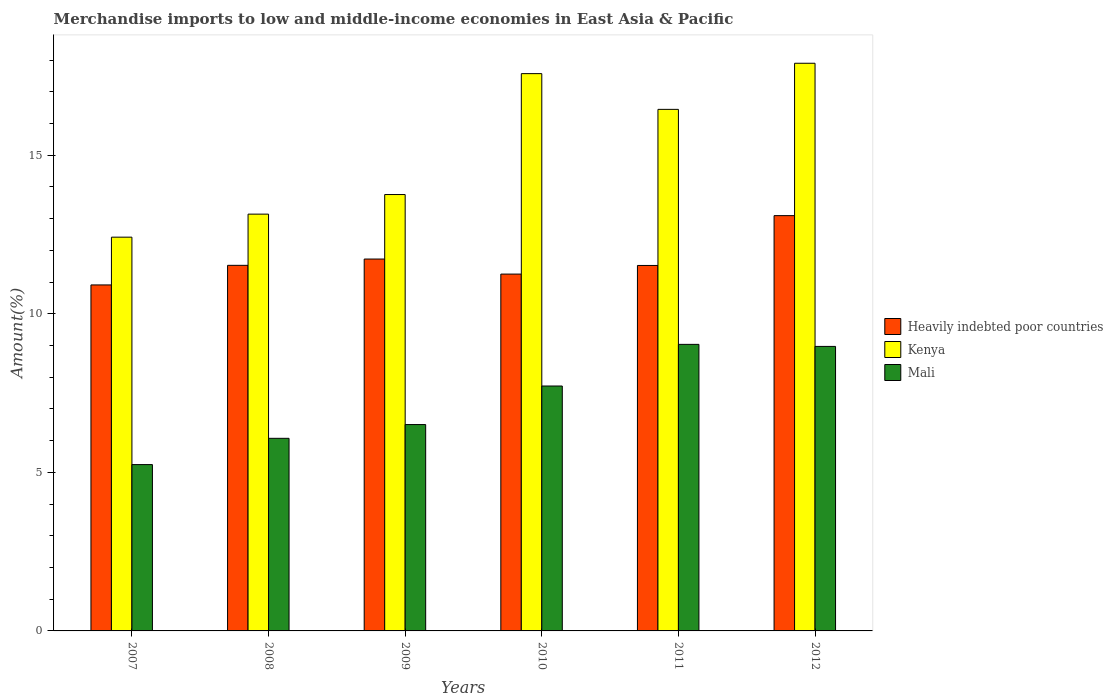How many groups of bars are there?
Your answer should be very brief. 6. How many bars are there on the 5th tick from the left?
Give a very brief answer. 3. How many bars are there on the 6th tick from the right?
Your answer should be compact. 3. In how many cases, is the number of bars for a given year not equal to the number of legend labels?
Your answer should be compact. 0. What is the percentage of amount earned from merchandise imports in Heavily indebted poor countries in 2009?
Provide a short and direct response. 11.73. Across all years, what is the maximum percentage of amount earned from merchandise imports in Kenya?
Offer a terse response. 17.9. Across all years, what is the minimum percentage of amount earned from merchandise imports in Kenya?
Provide a short and direct response. 12.42. What is the total percentage of amount earned from merchandise imports in Heavily indebted poor countries in the graph?
Make the answer very short. 70.03. What is the difference between the percentage of amount earned from merchandise imports in Kenya in 2010 and that in 2011?
Provide a short and direct response. 1.13. What is the difference between the percentage of amount earned from merchandise imports in Heavily indebted poor countries in 2011 and the percentage of amount earned from merchandise imports in Mali in 2009?
Provide a succinct answer. 5.02. What is the average percentage of amount earned from merchandise imports in Heavily indebted poor countries per year?
Your answer should be very brief. 11.67. In the year 2007, what is the difference between the percentage of amount earned from merchandise imports in Heavily indebted poor countries and percentage of amount earned from merchandise imports in Kenya?
Make the answer very short. -1.51. What is the ratio of the percentage of amount earned from merchandise imports in Heavily indebted poor countries in 2007 to that in 2009?
Your response must be concise. 0.93. Is the percentage of amount earned from merchandise imports in Heavily indebted poor countries in 2009 less than that in 2012?
Ensure brevity in your answer.  Yes. Is the difference between the percentage of amount earned from merchandise imports in Heavily indebted poor countries in 2008 and 2012 greater than the difference between the percentage of amount earned from merchandise imports in Kenya in 2008 and 2012?
Give a very brief answer. Yes. What is the difference between the highest and the second highest percentage of amount earned from merchandise imports in Heavily indebted poor countries?
Keep it short and to the point. 1.37. What is the difference between the highest and the lowest percentage of amount earned from merchandise imports in Kenya?
Your response must be concise. 5.48. Is the sum of the percentage of amount earned from merchandise imports in Mali in 2008 and 2010 greater than the maximum percentage of amount earned from merchandise imports in Kenya across all years?
Provide a succinct answer. No. What does the 2nd bar from the left in 2011 represents?
Give a very brief answer. Kenya. What does the 3rd bar from the right in 2011 represents?
Make the answer very short. Heavily indebted poor countries. How many bars are there?
Your response must be concise. 18. Are all the bars in the graph horizontal?
Your answer should be very brief. No. How many years are there in the graph?
Your response must be concise. 6. Are the values on the major ticks of Y-axis written in scientific E-notation?
Provide a short and direct response. No. How many legend labels are there?
Provide a succinct answer. 3. What is the title of the graph?
Give a very brief answer. Merchandise imports to low and middle-income economies in East Asia & Pacific. What is the label or title of the X-axis?
Your answer should be very brief. Years. What is the label or title of the Y-axis?
Provide a short and direct response. Amount(%). What is the Amount(%) in Heavily indebted poor countries in 2007?
Provide a short and direct response. 10.91. What is the Amount(%) of Kenya in 2007?
Offer a terse response. 12.42. What is the Amount(%) in Mali in 2007?
Provide a short and direct response. 5.24. What is the Amount(%) in Heavily indebted poor countries in 2008?
Offer a terse response. 11.53. What is the Amount(%) in Kenya in 2008?
Give a very brief answer. 13.14. What is the Amount(%) of Mali in 2008?
Your response must be concise. 6.07. What is the Amount(%) of Heavily indebted poor countries in 2009?
Your response must be concise. 11.73. What is the Amount(%) of Kenya in 2009?
Your answer should be very brief. 13.76. What is the Amount(%) in Mali in 2009?
Your answer should be compact. 6.51. What is the Amount(%) of Heavily indebted poor countries in 2010?
Offer a very short reply. 11.25. What is the Amount(%) of Kenya in 2010?
Ensure brevity in your answer.  17.57. What is the Amount(%) of Mali in 2010?
Offer a terse response. 7.72. What is the Amount(%) of Heavily indebted poor countries in 2011?
Your answer should be very brief. 11.52. What is the Amount(%) in Kenya in 2011?
Your response must be concise. 16.44. What is the Amount(%) of Mali in 2011?
Give a very brief answer. 9.04. What is the Amount(%) in Heavily indebted poor countries in 2012?
Your response must be concise. 13.09. What is the Amount(%) in Kenya in 2012?
Make the answer very short. 17.9. What is the Amount(%) in Mali in 2012?
Ensure brevity in your answer.  8.97. Across all years, what is the maximum Amount(%) of Heavily indebted poor countries?
Provide a succinct answer. 13.09. Across all years, what is the maximum Amount(%) of Kenya?
Ensure brevity in your answer.  17.9. Across all years, what is the maximum Amount(%) in Mali?
Keep it short and to the point. 9.04. Across all years, what is the minimum Amount(%) in Heavily indebted poor countries?
Your answer should be compact. 10.91. Across all years, what is the minimum Amount(%) in Kenya?
Provide a succinct answer. 12.42. Across all years, what is the minimum Amount(%) in Mali?
Ensure brevity in your answer.  5.24. What is the total Amount(%) of Heavily indebted poor countries in the graph?
Your response must be concise. 70.03. What is the total Amount(%) of Kenya in the graph?
Your response must be concise. 91.23. What is the total Amount(%) in Mali in the graph?
Ensure brevity in your answer.  43.55. What is the difference between the Amount(%) of Heavily indebted poor countries in 2007 and that in 2008?
Your answer should be compact. -0.62. What is the difference between the Amount(%) in Kenya in 2007 and that in 2008?
Give a very brief answer. -0.73. What is the difference between the Amount(%) in Mali in 2007 and that in 2008?
Ensure brevity in your answer.  -0.83. What is the difference between the Amount(%) of Heavily indebted poor countries in 2007 and that in 2009?
Provide a short and direct response. -0.82. What is the difference between the Amount(%) in Kenya in 2007 and that in 2009?
Give a very brief answer. -1.34. What is the difference between the Amount(%) of Mali in 2007 and that in 2009?
Your answer should be very brief. -1.26. What is the difference between the Amount(%) of Heavily indebted poor countries in 2007 and that in 2010?
Make the answer very short. -0.34. What is the difference between the Amount(%) in Kenya in 2007 and that in 2010?
Make the answer very short. -5.16. What is the difference between the Amount(%) in Mali in 2007 and that in 2010?
Provide a short and direct response. -2.48. What is the difference between the Amount(%) of Heavily indebted poor countries in 2007 and that in 2011?
Offer a very short reply. -0.61. What is the difference between the Amount(%) of Kenya in 2007 and that in 2011?
Keep it short and to the point. -4.03. What is the difference between the Amount(%) in Mali in 2007 and that in 2011?
Your response must be concise. -3.79. What is the difference between the Amount(%) in Heavily indebted poor countries in 2007 and that in 2012?
Provide a short and direct response. -2.19. What is the difference between the Amount(%) of Kenya in 2007 and that in 2012?
Keep it short and to the point. -5.48. What is the difference between the Amount(%) of Mali in 2007 and that in 2012?
Give a very brief answer. -3.73. What is the difference between the Amount(%) in Heavily indebted poor countries in 2008 and that in 2009?
Make the answer very short. -0.2. What is the difference between the Amount(%) of Kenya in 2008 and that in 2009?
Make the answer very short. -0.62. What is the difference between the Amount(%) in Mali in 2008 and that in 2009?
Offer a terse response. -0.43. What is the difference between the Amount(%) in Heavily indebted poor countries in 2008 and that in 2010?
Give a very brief answer. 0.28. What is the difference between the Amount(%) of Kenya in 2008 and that in 2010?
Keep it short and to the point. -4.43. What is the difference between the Amount(%) in Mali in 2008 and that in 2010?
Offer a terse response. -1.65. What is the difference between the Amount(%) of Heavily indebted poor countries in 2008 and that in 2011?
Your response must be concise. 0. What is the difference between the Amount(%) in Kenya in 2008 and that in 2011?
Give a very brief answer. -3.3. What is the difference between the Amount(%) of Mali in 2008 and that in 2011?
Give a very brief answer. -2.96. What is the difference between the Amount(%) in Heavily indebted poor countries in 2008 and that in 2012?
Provide a short and direct response. -1.57. What is the difference between the Amount(%) in Kenya in 2008 and that in 2012?
Give a very brief answer. -4.76. What is the difference between the Amount(%) in Mali in 2008 and that in 2012?
Offer a very short reply. -2.9. What is the difference between the Amount(%) of Heavily indebted poor countries in 2009 and that in 2010?
Provide a short and direct response. 0.47. What is the difference between the Amount(%) of Kenya in 2009 and that in 2010?
Give a very brief answer. -3.81. What is the difference between the Amount(%) of Mali in 2009 and that in 2010?
Provide a short and direct response. -1.22. What is the difference between the Amount(%) in Heavily indebted poor countries in 2009 and that in 2011?
Offer a terse response. 0.2. What is the difference between the Amount(%) in Kenya in 2009 and that in 2011?
Provide a short and direct response. -2.69. What is the difference between the Amount(%) of Mali in 2009 and that in 2011?
Keep it short and to the point. -2.53. What is the difference between the Amount(%) in Heavily indebted poor countries in 2009 and that in 2012?
Give a very brief answer. -1.37. What is the difference between the Amount(%) in Kenya in 2009 and that in 2012?
Provide a succinct answer. -4.14. What is the difference between the Amount(%) in Mali in 2009 and that in 2012?
Ensure brevity in your answer.  -2.46. What is the difference between the Amount(%) of Heavily indebted poor countries in 2010 and that in 2011?
Keep it short and to the point. -0.27. What is the difference between the Amount(%) of Kenya in 2010 and that in 2011?
Your answer should be compact. 1.13. What is the difference between the Amount(%) of Mali in 2010 and that in 2011?
Ensure brevity in your answer.  -1.31. What is the difference between the Amount(%) of Heavily indebted poor countries in 2010 and that in 2012?
Your answer should be very brief. -1.84. What is the difference between the Amount(%) in Kenya in 2010 and that in 2012?
Keep it short and to the point. -0.33. What is the difference between the Amount(%) in Mali in 2010 and that in 2012?
Offer a terse response. -1.25. What is the difference between the Amount(%) of Heavily indebted poor countries in 2011 and that in 2012?
Make the answer very short. -1.57. What is the difference between the Amount(%) of Kenya in 2011 and that in 2012?
Make the answer very short. -1.45. What is the difference between the Amount(%) of Mali in 2011 and that in 2012?
Your answer should be very brief. 0.06. What is the difference between the Amount(%) of Heavily indebted poor countries in 2007 and the Amount(%) of Kenya in 2008?
Ensure brevity in your answer.  -2.23. What is the difference between the Amount(%) of Heavily indebted poor countries in 2007 and the Amount(%) of Mali in 2008?
Provide a succinct answer. 4.84. What is the difference between the Amount(%) in Kenya in 2007 and the Amount(%) in Mali in 2008?
Your response must be concise. 6.34. What is the difference between the Amount(%) in Heavily indebted poor countries in 2007 and the Amount(%) in Kenya in 2009?
Offer a very short reply. -2.85. What is the difference between the Amount(%) of Heavily indebted poor countries in 2007 and the Amount(%) of Mali in 2009?
Give a very brief answer. 4.4. What is the difference between the Amount(%) of Kenya in 2007 and the Amount(%) of Mali in 2009?
Offer a very short reply. 5.91. What is the difference between the Amount(%) of Heavily indebted poor countries in 2007 and the Amount(%) of Kenya in 2010?
Your response must be concise. -6.66. What is the difference between the Amount(%) in Heavily indebted poor countries in 2007 and the Amount(%) in Mali in 2010?
Your response must be concise. 3.19. What is the difference between the Amount(%) in Kenya in 2007 and the Amount(%) in Mali in 2010?
Your answer should be compact. 4.69. What is the difference between the Amount(%) of Heavily indebted poor countries in 2007 and the Amount(%) of Kenya in 2011?
Your answer should be very brief. -5.54. What is the difference between the Amount(%) of Heavily indebted poor countries in 2007 and the Amount(%) of Mali in 2011?
Your response must be concise. 1.87. What is the difference between the Amount(%) in Kenya in 2007 and the Amount(%) in Mali in 2011?
Your answer should be compact. 3.38. What is the difference between the Amount(%) of Heavily indebted poor countries in 2007 and the Amount(%) of Kenya in 2012?
Give a very brief answer. -6.99. What is the difference between the Amount(%) of Heavily indebted poor countries in 2007 and the Amount(%) of Mali in 2012?
Offer a very short reply. 1.94. What is the difference between the Amount(%) in Kenya in 2007 and the Amount(%) in Mali in 2012?
Your response must be concise. 3.44. What is the difference between the Amount(%) in Heavily indebted poor countries in 2008 and the Amount(%) in Kenya in 2009?
Make the answer very short. -2.23. What is the difference between the Amount(%) of Heavily indebted poor countries in 2008 and the Amount(%) of Mali in 2009?
Your answer should be very brief. 5.02. What is the difference between the Amount(%) of Kenya in 2008 and the Amount(%) of Mali in 2009?
Your answer should be very brief. 6.63. What is the difference between the Amount(%) of Heavily indebted poor countries in 2008 and the Amount(%) of Kenya in 2010?
Your answer should be compact. -6.04. What is the difference between the Amount(%) of Heavily indebted poor countries in 2008 and the Amount(%) of Mali in 2010?
Keep it short and to the point. 3.8. What is the difference between the Amount(%) in Kenya in 2008 and the Amount(%) in Mali in 2010?
Give a very brief answer. 5.42. What is the difference between the Amount(%) of Heavily indebted poor countries in 2008 and the Amount(%) of Kenya in 2011?
Your answer should be compact. -4.92. What is the difference between the Amount(%) of Heavily indebted poor countries in 2008 and the Amount(%) of Mali in 2011?
Offer a terse response. 2.49. What is the difference between the Amount(%) of Kenya in 2008 and the Amount(%) of Mali in 2011?
Provide a short and direct response. 4.11. What is the difference between the Amount(%) of Heavily indebted poor countries in 2008 and the Amount(%) of Kenya in 2012?
Your response must be concise. -6.37. What is the difference between the Amount(%) in Heavily indebted poor countries in 2008 and the Amount(%) in Mali in 2012?
Make the answer very short. 2.56. What is the difference between the Amount(%) in Kenya in 2008 and the Amount(%) in Mali in 2012?
Provide a succinct answer. 4.17. What is the difference between the Amount(%) of Heavily indebted poor countries in 2009 and the Amount(%) of Kenya in 2010?
Provide a short and direct response. -5.85. What is the difference between the Amount(%) in Heavily indebted poor countries in 2009 and the Amount(%) in Mali in 2010?
Offer a terse response. 4. What is the difference between the Amount(%) of Kenya in 2009 and the Amount(%) of Mali in 2010?
Keep it short and to the point. 6.04. What is the difference between the Amount(%) of Heavily indebted poor countries in 2009 and the Amount(%) of Kenya in 2011?
Provide a short and direct response. -4.72. What is the difference between the Amount(%) in Heavily indebted poor countries in 2009 and the Amount(%) in Mali in 2011?
Provide a short and direct response. 2.69. What is the difference between the Amount(%) of Kenya in 2009 and the Amount(%) of Mali in 2011?
Ensure brevity in your answer.  4.72. What is the difference between the Amount(%) in Heavily indebted poor countries in 2009 and the Amount(%) in Kenya in 2012?
Make the answer very short. -6.17. What is the difference between the Amount(%) of Heavily indebted poor countries in 2009 and the Amount(%) of Mali in 2012?
Give a very brief answer. 2.76. What is the difference between the Amount(%) in Kenya in 2009 and the Amount(%) in Mali in 2012?
Your answer should be compact. 4.79. What is the difference between the Amount(%) of Heavily indebted poor countries in 2010 and the Amount(%) of Kenya in 2011?
Provide a short and direct response. -5.19. What is the difference between the Amount(%) of Heavily indebted poor countries in 2010 and the Amount(%) of Mali in 2011?
Your answer should be very brief. 2.22. What is the difference between the Amount(%) in Kenya in 2010 and the Amount(%) in Mali in 2011?
Ensure brevity in your answer.  8.54. What is the difference between the Amount(%) of Heavily indebted poor countries in 2010 and the Amount(%) of Kenya in 2012?
Ensure brevity in your answer.  -6.65. What is the difference between the Amount(%) of Heavily indebted poor countries in 2010 and the Amount(%) of Mali in 2012?
Make the answer very short. 2.28. What is the difference between the Amount(%) in Kenya in 2010 and the Amount(%) in Mali in 2012?
Provide a succinct answer. 8.6. What is the difference between the Amount(%) of Heavily indebted poor countries in 2011 and the Amount(%) of Kenya in 2012?
Keep it short and to the point. -6.38. What is the difference between the Amount(%) in Heavily indebted poor countries in 2011 and the Amount(%) in Mali in 2012?
Offer a very short reply. 2.55. What is the difference between the Amount(%) in Kenya in 2011 and the Amount(%) in Mali in 2012?
Offer a terse response. 7.47. What is the average Amount(%) in Heavily indebted poor countries per year?
Your answer should be very brief. 11.67. What is the average Amount(%) in Kenya per year?
Keep it short and to the point. 15.21. What is the average Amount(%) in Mali per year?
Offer a terse response. 7.26. In the year 2007, what is the difference between the Amount(%) in Heavily indebted poor countries and Amount(%) in Kenya?
Make the answer very short. -1.51. In the year 2007, what is the difference between the Amount(%) in Heavily indebted poor countries and Amount(%) in Mali?
Keep it short and to the point. 5.66. In the year 2007, what is the difference between the Amount(%) of Kenya and Amount(%) of Mali?
Make the answer very short. 7.17. In the year 2008, what is the difference between the Amount(%) in Heavily indebted poor countries and Amount(%) in Kenya?
Give a very brief answer. -1.61. In the year 2008, what is the difference between the Amount(%) in Heavily indebted poor countries and Amount(%) in Mali?
Offer a very short reply. 5.45. In the year 2008, what is the difference between the Amount(%) in Kenya and Amount(%) in Mali?
Make the answer very short. 7.07. In the year 2009, what is the difference between the Amount(%) in Heavily indebted poor countries and Amount(%) in Kenya?
Keep it short and to the point. -2.03. In the year 2009, what is the difference between the Amount(%) of Heavily indebted poor countries and Amount(%) of Mali?
Your answer should be compact. 5.22. In the year 2009, what is the difference between the Amount(%) in Kenya and Amount(%) in Mali?
Your response must be concise. 7.25. In the year 2010, what is the difference between the Amount(%) of Heavily indebted poor countries and Amount(%) of Kenya?
Make the answer very short. -6.32. In the year 2010, what is the difference between the Amount(%) of Heavily indebted poor countries and Amount(%) of Mali?
Provide a succinct answer. 3.53. In the year 2010, what is the difference between the Amount(%) in Kenya and Amount(%) in Mali?
Keep it short and to the point. 9.85. In the year 2011, what is the difference between the Amount(%) of Heavily indebted poor countries and Amount(%) of Kenya?
Your answer should be very brief. -4.92. In the year 2011, what is the difference between the Amount(%) of Heavily indebted poor countries and Amount(%) of Mali?
Your answer should be compact. 2.49. In the year 2011, what is the difference between the Amount(%) in Kenya and Amount(%) in Mali?
Provide a succinct answer. 7.41. In the year 2012, what is the difference between the Amount(%) of Heavily indebted poor countries and Amount(%) of Kenya?
Keep it short and to the point. -4.8. In the year 2012, what is the difference between the Amount(%) in Heavily indebted poor countries and Amount(%) in Mali?
Offer a terse response. 4.12. In the year 2012, what is the difference between the Amount(%) in Kenya and Amount(%) in Mali?
Your answer should be very brief. 8.93. What is the ratio of the Amount(%) in Heavily indebted poor countries in 2007 to that in 2008?
Offer a very short reply. 0.95. What is the ratio of the Amount(%) in Kenya in 2007 to that in 2008?
Offer a very short reply. 0.94. What is the ratio of the Amount(%) of Mali in 2007 to that in 2008?
Your answer should be very brief. 0.86. What is the ratio of the Amount(%) in Heavily indebted poor countries in 2007 to that in 2009?
Provide a short and direct response. 0.93. What is the ratio of the Amount(%) of Kenya in 2007 to that in 2009?
Offer a terse response. 0.9. What is the ratio of the Amount(%) in Mali in 2007 to that in 2009?
Your response must be concise. 0.81. What is the ratio of the Amount(%) in Heavily indebted poor countries in 2007 to that in 2010?
Make the answer very short. 0.97. What is the ratio of the Amount(%) in Kenya in 2007 to that in 2010?
Provide a succinct answer. 0.71. What is the ratio of the Amount(%) in Mali in 2007 to that in 2010?
Keep it short and to the point. 0.68. What is the ratio of the Amount(%) of Heavily indebted poor countries in 2007 to that in 2011?
Provide a short and direct response. 0.95. What is the ratio of the Amount(%) in Kenya in 2007 to that in 2011?
Provide a short and direct response. 0.76. What is the ratio of the Amount(%) in Mali in 2007 to that in 2011?
Keep it short and to the point. 0.58. What is the ratio of the Amount(%) of Heavily indebted poor countries in 2007 to that in 2012?
Your answer should be very brief. 0.83. What is the ratio of the Amount(%) in Kenya in 2007 to that in 2012?
Provide a short and direct response. 0.69. What is the ratio of the Amount(%) in Mali in 2007 to that in 2012?
Make the answer very short. 0.58. What is the ratio of the Amount(%) of Heavily indebted poor countries in 2008 to that in 2009?
Offer a very short reply. 0.98. What is the ratio of the Amount(%) of Kenya in 2008 to that in 2009?
Give a very brief answer. 0.96. What is the ratio of the Amount(%) of Mali in 2008 to that in 2009?
Make the answer very short. 0.93. What is the ratio of the Amount(%) of Heavily indebted poor countries in 2008 to that in 2010?
Your answer should be very brief. 1.02. What is the ratio of the Amount(%) of Kenya in 2008 to that in 2010?
Your response must be concise. 0.75. What is the ratio of the Amount(%) of Mali in 2008 to that in 2010?
Provide a short and direct response. 0.79. What is the ratio of the Amount(%) in Heavily indebted poor countries in 2008 to that in 2011?
Provide a short and direct response. 1. What is the ratio of the Amount(%) of Kenya in 2008 to that in 2011?
Offer a terse response. 0.8. What is the ratio of the Amount(%) in Mali in 2008 to that in 2011?
Your answer should be compact. 0.67. What is the ratio of the Amount(%) of Heavily indebted poor countries in 2008 to that in 2012?
Offer a very short reply. 0.88. What is the ratio of the Amount(%) in Kenya in 2008 to that in 2012?
Give a very brief answer. 0.73. What is the ratio of the Amount(%) in Mali in 2008 to that in 2012?
Your answer should be very brief. 0.68. What is the ratio of the Amount(%) in Heavily indebted poor countries in 2009 to that in 2010?
Offer a very short reply. 1.04. What is the ratio of the Amount(%) in Kenya in 2009 to that in 2010?
Your answer should be very brief. 0.78. What is the ratio of the Amount(%) of Mali in 2009 to that in 2010?
Give a very brief answer. 0.84. What is the ratio of the Amount(%) in Heavily indebted poor countries in 2009 to that in 2011?
Give a very brief answer. 1.02. What is the ratio of the Amount(%) in Kenya in 2009 to that in 2011?
Your answer should be very brief. 0.84. What is the ratio of the Amount(%) of Mali in 2009 to that in 2011?
Your answer should be very brief. 0.72. What is the ratio of the Amount(%) in Heavily indebted poor countries in 2009 to that in 2012?
Keep it short and to the point. 0.9. What is the ratio of the Amount(%) of Kenya in 2009 to that in 2012?
Your answer should be very brief. 0.77. What is the ratio of the Amount(%) of Mali in 2009 to that in 2012?
Offer a terse response. 0.73. What is the ratio of the Amount(%) in Heavily indebted poor countries in 2010 to that in 2011?
Give a very brief answer. 0.98. What is the ratio of the Amount(%) of Kenya in 2010 to that in 2011?
Keep it short and to the point. 1.07. What is the ratio of the Amount(%) in Mali in 2010 to that in 2011?
Your response must be concise. 0.85. What is the ratio of the Amount(%) of Heavily indebted poor countries in 2010 to that in 2012?
Provide a succinct answer. 0.86. What is the ratio of the Amount(%) in Kenya in 2010 to that in 2012?
Keep it short and to the point. 0.98. What is the ratio of the Amount(%) in Mali in 2010 to that in 2012?
Provide a succinct answer. 0.86. What is the ratio of the Amount(%) in Heavily indebted poor countries in 2011 to that in 2012?
Make the answer very short. 0.88. What is the ratio of the Amount(%) in Kenya in 2011 to that in 2012?
Offer a terse response. 0.92. What is the ratio of the Amount(%) in Mali in 2011 to that in 2012?
Offer a very short reply. 1.01. What is the difference between the highest and the second highest Amount(%) of Heavily indebted poor countries?
Offer a terse response. 1.37. What is the difference between the highest and the second highest Amount(%) in Kenya?
Your answer should be compact. 0.33. What is the difference between the highest and the second highest Amount(%) of Mali?
Your response must be concise. 0.06. What is the difference between the highest and the lowest Amount(%) of Heavily indebted poor countries?
Keep it short and to the point. 2.19. What is the difference between the highest and the lowest Amount(%) in Kenya?
Your response must be concise. 5.48. What is the difference between the highest and the lowest Amount(%) of Mali?
Your response must be concise. 3.79. 